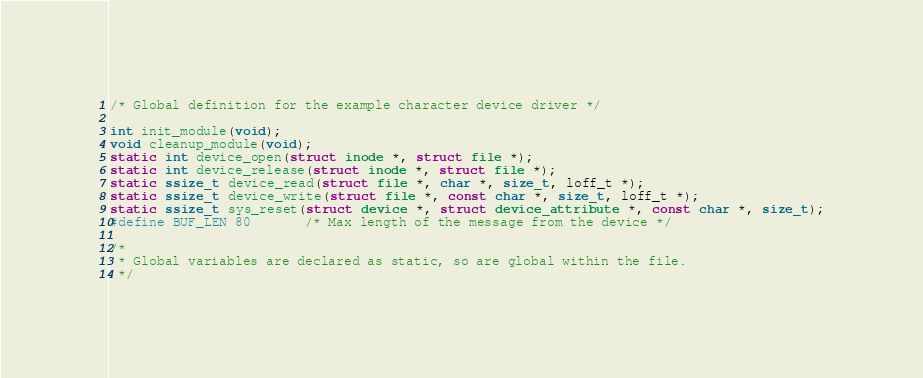Convert code to text. <code><loc_0><loc_0><loc_500><loc_500><_C_>/* Global definition for the example character device driver */

int init_module(void);
void cleanup_module(void);
static int device_open(struct inode *, struct file *);
static int device_release(struct inode *, struct file *);
static ssize_t device_read(struct file *, char *, size_t, loff_t *);
static ssize_t device_write(struct file *, const char *, size_t, loff_t *);
static ssize_t sys_reset(struct device *, struct device_attribute *, const char *, size_t);
#define BUF_LEN 80		/* Max length of the message from the device */

/* 
 * Global variables are declared as static, so are global within the file. 
 */</code> 